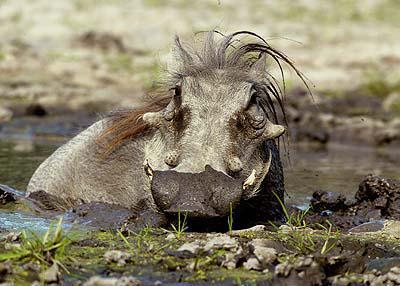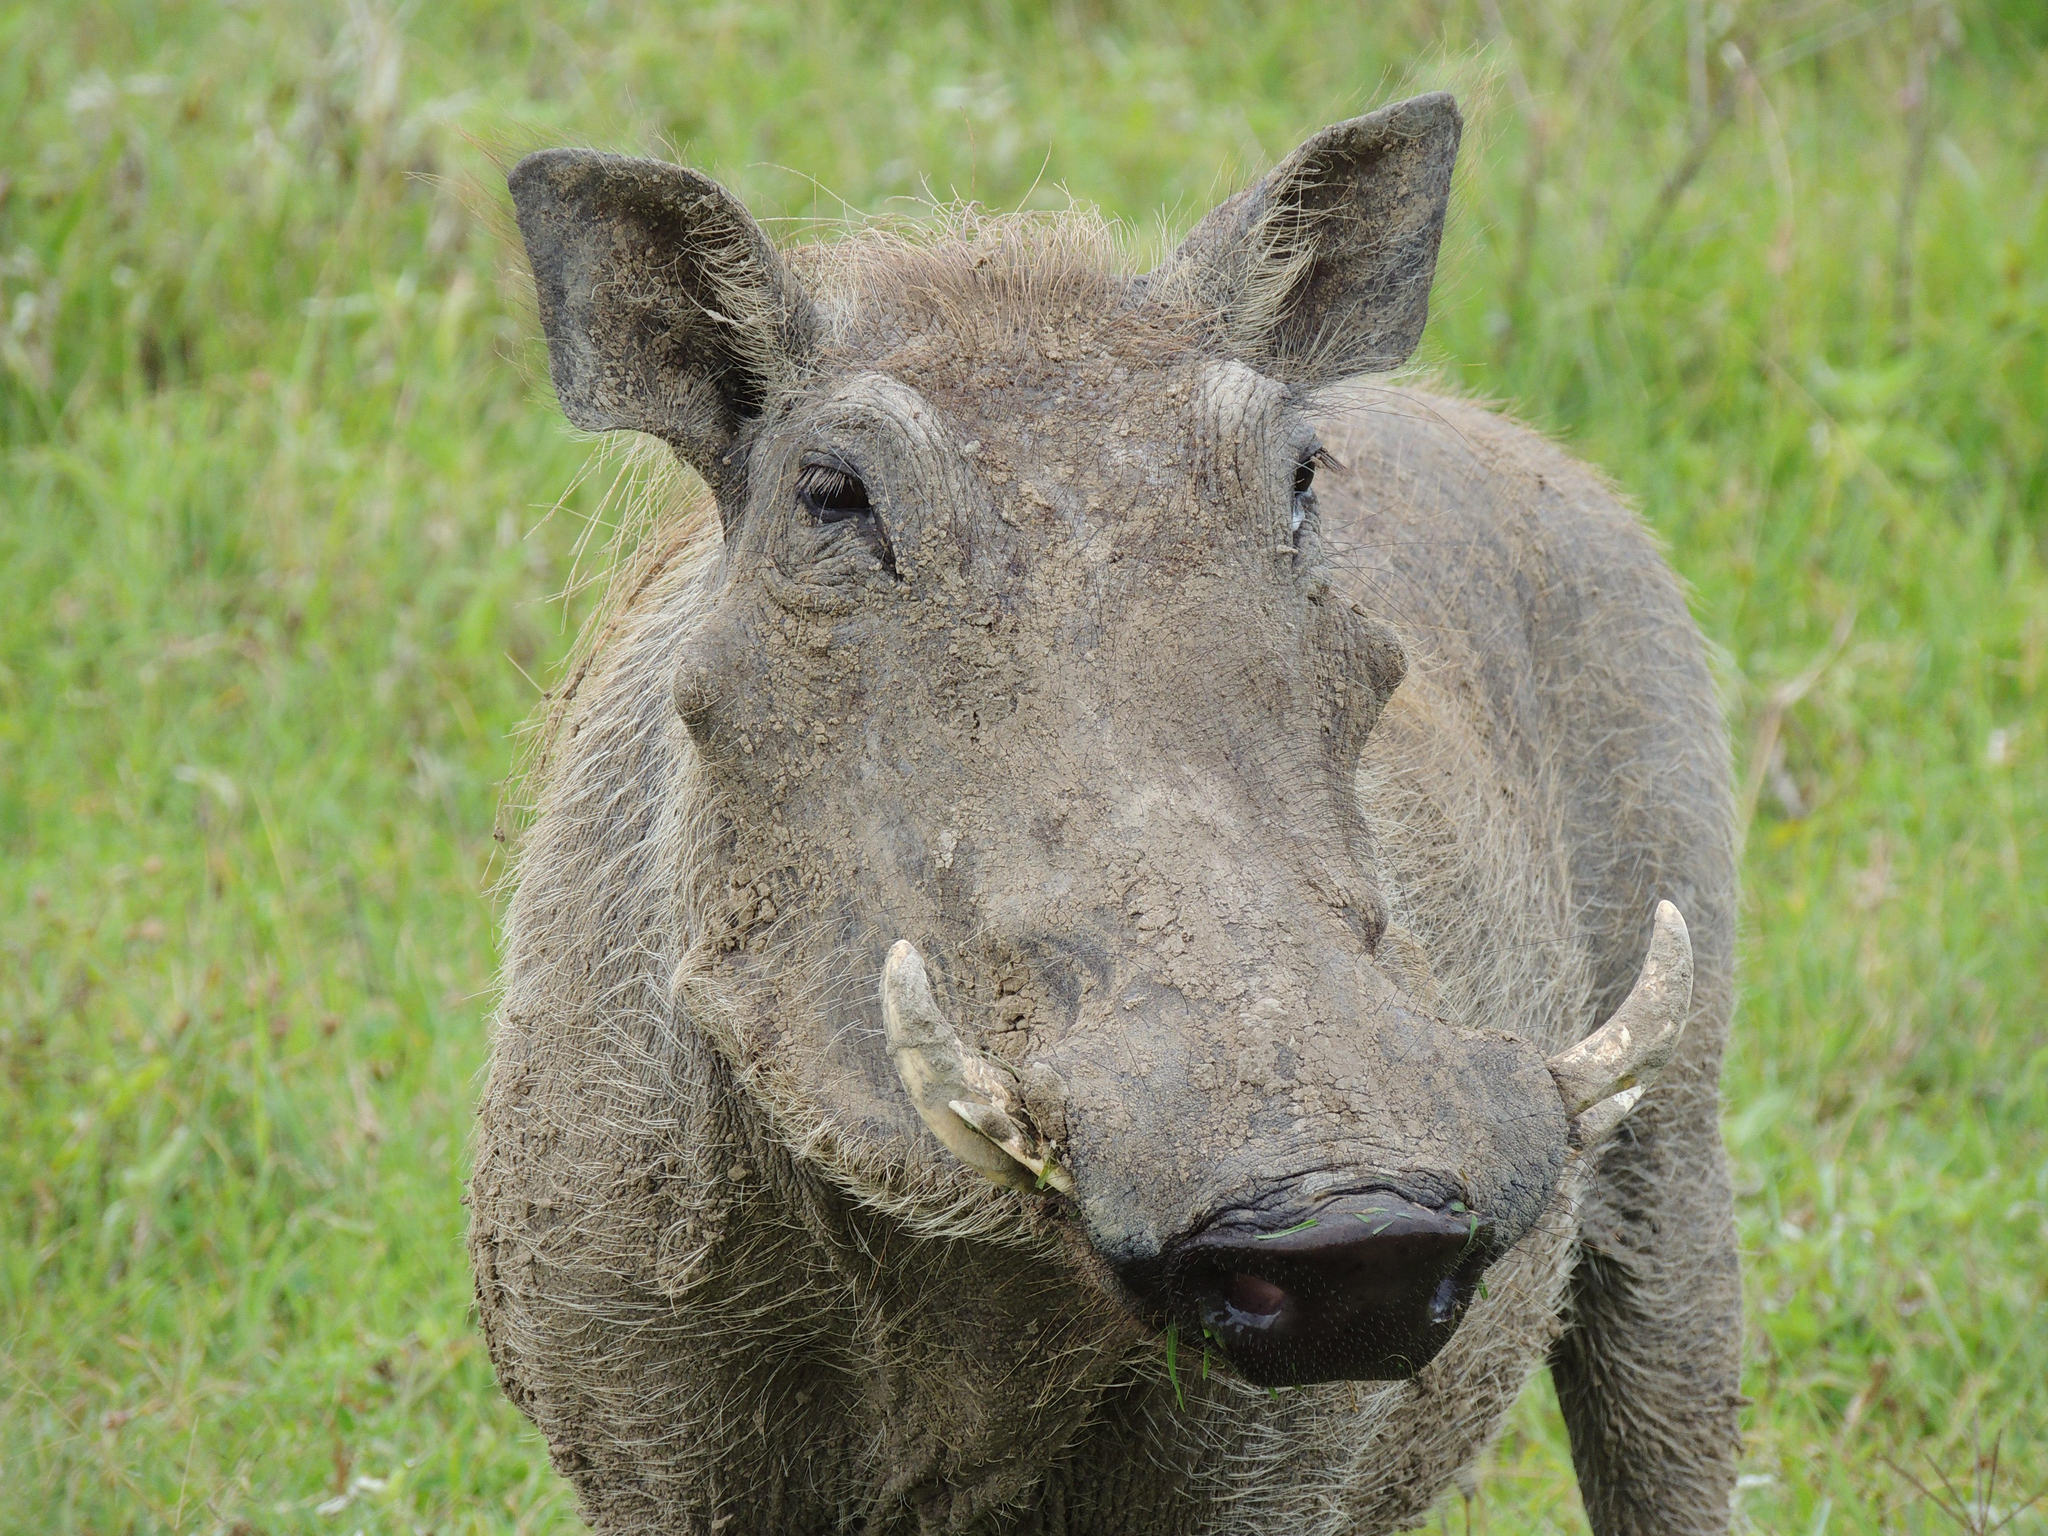The first image is the image on the left, the second image is the image on the right. For the images shown, is this caption "An image shows at least one mammal behind the hog in the foreground." true? Answer yes or no. No. 